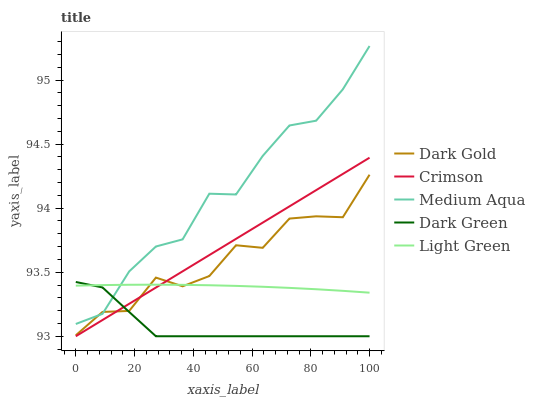Does Dark Green have the minimum area under the curve?
Answer yes or no. Yes. Does Medium Aqua have the maximum area under the curve?
Answer yes or no. Yes. Does Medium Aqua have the minimum area under the curve?
Answer yes or no. No. Does Dark Green have the maximum area under the curve?
Answer yes or no. No. Is Crimson the smoothest?
Answer yes or no. Yes. Is Dark Gold the roughest?
Answer yes or no. Yes. Is Dark Green the smoothest?
Answer yes or no. No. Is Dark Green the roughest?
Answer yes or no. No. Does Crimson have the lowest value?
Answer yes or no. Yes. Does Medium Aqua have the lowest value?
Answer yes or no. No. Does Medium Aqua have the highest value?
Answer yes or no. Yes. Does Dark Green have the highest value?
Answer yes or no. No. Is Crimson less than Medium Aqua?
Answer yes or no. Yes. Is Medium Aqua greater than Crimson?
Answer yes or no. Yes. Does Medium Aqua intersect Dark Green?
Answer yes or no. Yes. Is Medium Aqua less than Dark Green?
Answer yes or no. No. Is Medium Aqua greater than Dark Green?
Answer yes or no. No. Does Crimson intersect Medium Aqua?
Answer yes or no. No. 